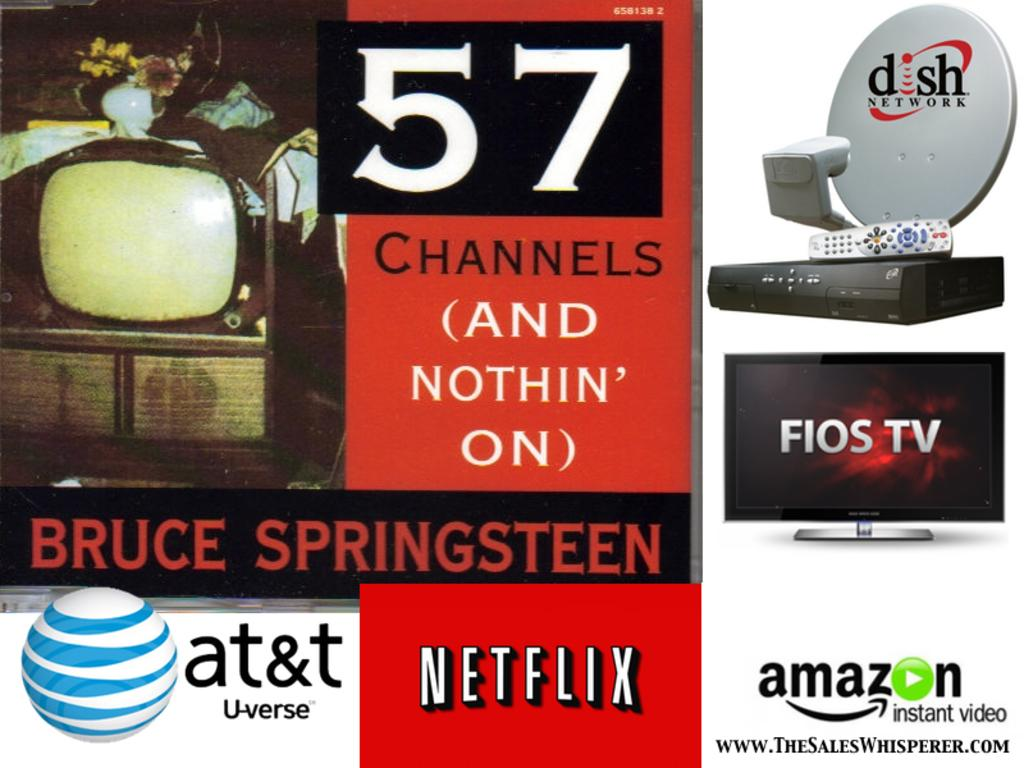<image>
Render a clear and concise summary of the photo. A collage of logos for netflix, amazon and dish network. 